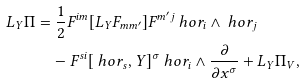Convert formula to latex. <formula><loc_0><loc_0><loc_500><loc_500>L _ { Y } \Pi & = \frac { 1 } { 2 } F ^ { i m } [ L _ { Y } F _ { m m ^ { \prime } } ] F ^ { m ^ { \prime } j } \ h o r _ { i } \wedge \ h o r _ { j } \\ & \quad - F ^ { s i } [ \ h o r _ { s } , Y ] ^ { \sigma } \ h o r _ { i } \wedge \frac { \partial } { \partial x ^ { \sigma } } + L _ { Y } \Pi _ { V } ,</formula> 